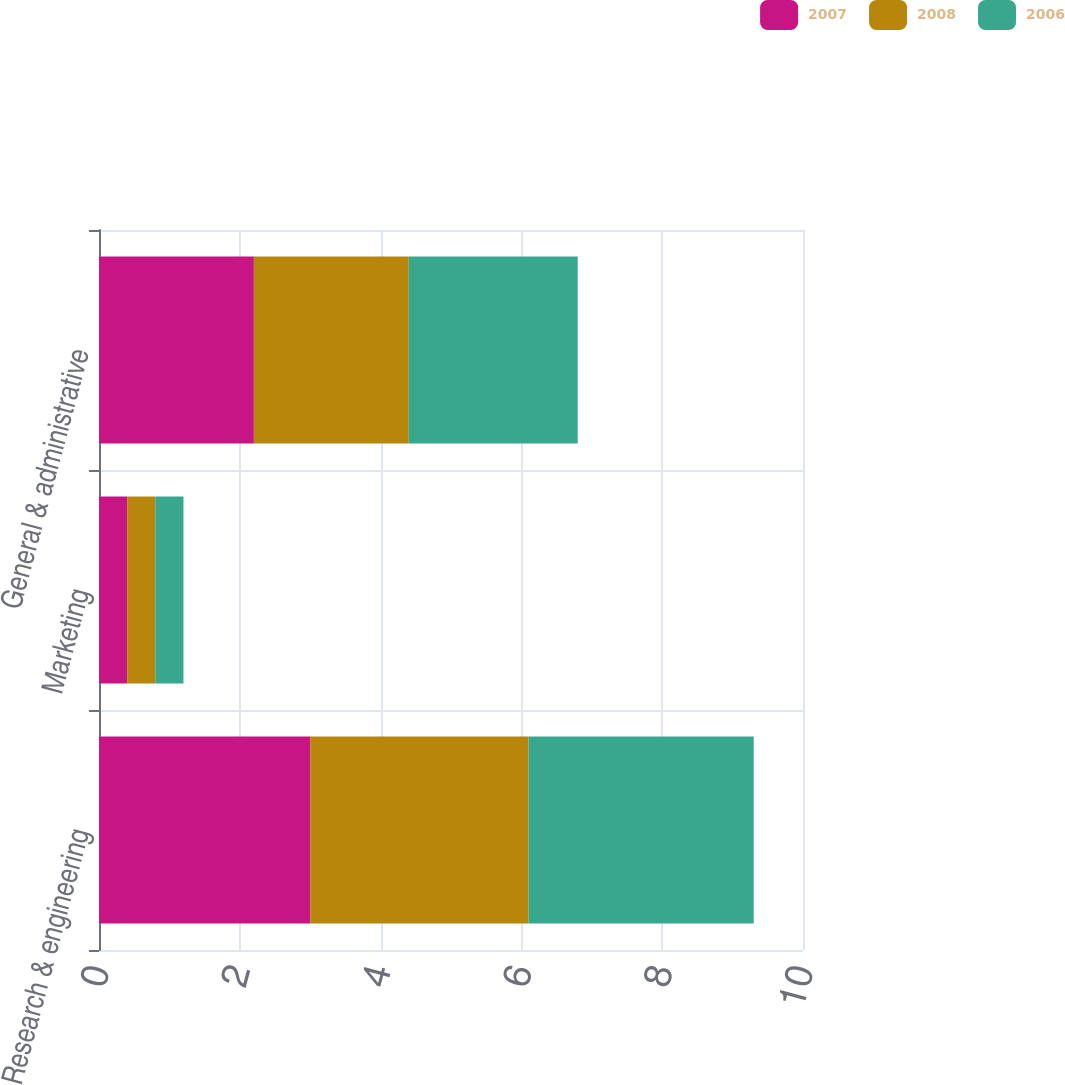Convert chart to OTSL. <chart><loc_0><loc_0><loc_500><loc_500><stacked_bar_chart><ecel><fcel>Research & engineering<fcel>Marketing<fcel>General & administrative<nl><fcel>2007<fcel>3<fcel>0.4<fcel>2.2<nl><fcel>2008<fcel>3.1<fcel>0.4<fcel>2.2<nl><fcel>2006<fcel>3.2<fcel>0.4<fcel>2.4<nl></chart> 